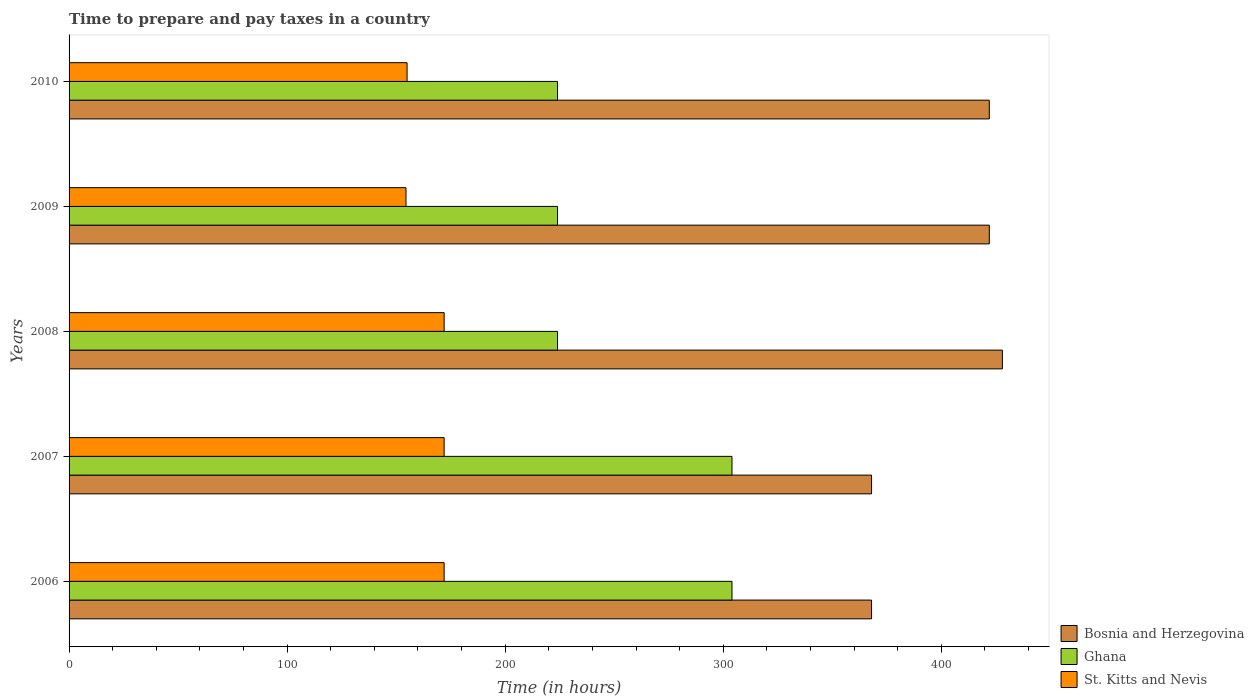Are the number of bars on each tick of the Y-axis equal?
Your answer should be very brief. Yes. How many bars are there on the 5th tick from the top?
Your response must be concise. 3. How many bars are there on the 3rd tick from the bottom?
Keep it short and to the point. 3. What is the number of hours required to prepare and pay taxes in Bosnia and Herzegovina in 2010?
Keep it short and to the point. 422. Across all years, what is the maximum number of hours required to prepare and pay taxes in Ghana?
Offer a terse response. 304. Across all years, what is the minimum number of hours required to prepare and pay taxes in Ghana?
Give a very brief answer. 224. In which year was the number of hours required to prepare and pay taxes in Ghana maximum?
Your response must be concise. 2006. In which year was the number of hours required to prepare and pay taxes in Bosnia and Herzegovina minimum?
Offer a very short reply. 2006. What is the total number of hours required to prepare and pay taxes in Ghana in the graph?
Ensure brevity in your answer.  1280. What is the difference between the number of hours required to prepare and pay taxes in St. Kitts and Nevis in 2007 and that in 2010?
Give a very brief answer. 17. What is the difference between the number of hours required to prepare and pay taxes in Bosnia and Herzegovina in 2008 and the number of hours required to prepare and pay taxes in Ghana in 2007?
Provide a short and direct response. 124. What is the average number of hours required to prepare and pay taxes in Bosnia and Herzegovina per year?
Your response must be concise. 401.6. In the year 2008, what is the difference between the number of hours required to prepare and pay taxes in Bosnia and Herzegovina and number of hours required to prepare and pay taxes in St. Kitts and Nevis?
Provide a succinct answer. 256. What is the ratio of the number of hours required to prepare and pay taxes in Bosnia and Herzegovina in 2008 to that in 2009?
Make the answer very short. 1.01. Is the difference between the number of hours required to prepare and pay taxes in Bosnia and Herzegovina in 2006 and 2009 greater than the difference between the number of hours required to prepare and pay taxes in St. Kitts and Nevis in 2006 and 2009?
Your answer should be compact. No. What is the difference between the highest and the second highest number of hours required to prepare and pay taxes in Ghana?
Offer a very short reply. 0. What is the difference between the highest and the lowest number of hours required to prepare and pay taxes in Ghana?
Offer a very short reply. 80. In how many years, is the number of hours required to prepare and pay taxes in Ghana greater than the average number of hours required to prepare and pay taxes in Ghana taken over all years?
Your response must be concise. 2. Is the sum of the number of hours required to prepare and pay taxes in Ghana in 2007 and 2008 greater than the maximum number of hours required to prepare and pay taxes in Bosnia and Herzegovina across all years?
Keep it short and to the point. Yes. What does the 1st bar from the top in 2006 represents?
Your answer should be compact. St. Kitts and Nevis. Is it the case that in every year, the sum of the number of hours required to prepare and pay taxes in Bosnia and Herzegovina and number of hours required to prepare and pay taxes in Ghana is greater than the number of hours required to prepare and pay taxes in St. Kitts and Nevis?
Ensure brevity in your answer.  Yes. What is the difference between two consecutive major ticks on the X-axis?
Provide a succinct answer. 100. Are the values on the major ticks of X-axis written in scientific E-notation?
Offer a very short reply. No. Does the graph contain any zero values?
Offer a terse response. No. Where does the legend appear in the graph?
Offer a terse response. Bottom right. How many legend labels are there?
Your response must be concise. 3. What is the title of the graph?
Provide a short and direct response. Time to prepare and pay taxes in a country. Does "Kenya" appear as one of the legend labels in the graph?
Offer a terse response. No. What is the label or title of the X-axis?
Offer a terse response. Time (in hours). What is the label or title of the Y-axis?
Your answer should be very brief. Years. What is the Time (in hours) of Bosnia and Herzegovina in 2006?
Offer a very short reply. 368. What is the Time (in hours) of Ghana in 2006?
Give a very brief answer. 304. What is the Time (in hours) of St. Kitts and Nevis in 2006?
Provide a succinct answer. 172. What is the Time (in hours) in Bosnia and Herzegovina in 2007?
Provide a short and direct response. 368. What is the Time (in hours) of Ghana in 2007?
Your answer should be compact. 304. What is the Time (in hours) in St. Kitts and Nevis in 2007?
Provide a short and direct response. 172. What is the Time (in hours) of Bosnia and Herzegovina in 2008?
Keep it short and to the point. 428. What is the Time (in hours) of Ghana in 2008?
Provide a succinct answer. 224. What is the Time (in hours) of St. Kitts and Nevis in 2008?
Provide a short and direct response. 172. What is the Time (in hours) of Bosnia and Herzegovina in 2009?
Provide a short and direct response. 422. What is the Time (in hours) of Ghana in 2009?
Offer a terse response. 224. What is the Time (in hours) of St. Kitts and Nevis in 2009?
Offer a very short reply. 154.5. What is the Time (in hours) in Bosnia and Herzegovina in 2010?
Keep it short and to the point. 422. What is the Time (in hours) in Ghana in 2010?
Give a very brief answer. 224. What is the Time (in hours) in St. Kitts and Nevis in 2010?
Your answer should be compact. 155. Across all years, what is the maximum Time (in hours) of Bosnia and Herzegovina?
Ensure brevity in your answer.  428. Across all years, what is the maximum Time (in hours) in Ghana?
Give a very brief answer. 304. Across all years, what is the maximum Time (in hours) in St. Kitts and Nevis?
Keep it short and to the point. 172. Across all years, what is the minimum Time (in hours) in Bosnia and Herzegovina?
Keep it short and to the point. 368. Across all years, what is the minimum Time (in hours) of Ghana?
Give a very brief answer. 224. Across all years, what is the minimum Time (in hours) in St. Kitts and Nevis?
Offer a very short reply. 154.5. What is the total Time (in hours) in Bosnia and Herzegovina in the graph?
Your answer should be very brief. 2008. What is the total Time (in hours) of Ghana in the graph?
Offer a terse response. 1280. What is the total Time (in hours) in St. Kitts and Nevis in the graph?
Provide a short and direct response. 825.5. What is the difference between the Time (in hours) of Bosnia and Herzegovina in 2006 and that in 2007?
Give a very brief answer. 0. What is the difference between the Time (in hours) in Ghana in 2006 and that in 2007?
Give a very brief answer. 0. What is the difference between the Time (in hours) of St. Kitts and Nevis in 2006 and that in 2007?
Keep it short and to the point. 0. What is the difference between the Time (in hours) in Bosnia and Herzegovina in 2006 and that in 2008?
Give a very brief answer. -60. What is the difference between the Time (in hours) in St. Kitts and Nevis in 2006 and that in 2008?
Provide a succinct answer. 0. What is the difference between the Time (in hours) of Bosnia and Herzegovina in 2006 and that in 2009?
Your response must be concise. -54. What is the difference between the Time (in hours) in Ghana in 2006 and that in 2009?
Your answer should be compact. 80. What is the difference between the Time (in hours) in St. Kitts and Nevis in 2006 and that in 2009?
Offer a very short reply. 17.5. What is the difference between the Time (in hours) in Bosnia and Herzegovina in 2006 and that in 2010?
Offer a terse response. -54. What is the difference between the Time (in hours) of Ghana in 2006 and that in 2010?
Provide a short and direct response. 80. What is the difference between the Time (in hours) in Bosnia and Herzegovina in 2007 and that in 2008?
Your answer should be compact. -60. What is the difference between the Time (in hours) in Ghana in 2007 and that in 2008?
Keep it short and to the point. 80. What is the difference between the Time (in hours) of Bosnia and Herzegovina in 2007 and that in 2009?
Make the answer very short. -54. What is the difference between the Time (in hours) of Bosnia and Herzegovina in 2007 and that in 2010?
Provide a succinct answer. -54. What is the difference between the Time (in hours) of Ghana in 2007 and that in 2010?
Offer a terse response. 80. What is the difference between the Time (in hours) of Ghana in 2008 and that in 2009?
Offer a terse response. 0. What is the difference between the Time (in hours) of Bosnia and Herzegovina in 2008 and that in 2010?
Offer a terse response. 6. What is the difference between the Time (in hours) of Ghana in 2008 and that in 2010?
Your response must be concise. 0. What is the difference between the Time (in hours) of St. Kitts and Nevis in 2008 and that in 2010?
Your answer should be very brief. 17. What is the difference between the Time (in hours) of Bosnia and Herzegovina in 2006 and the Time (in hours) of Ghana in 2007?
Make the answer very short. 64. What is the difference between the Time (in hours) in Bosnia and Herzegovina in 2006 and the Time (in hours) in St. Kitts and Nevis in 2007?
Offer a terse response. 196. What is the difference between the Time (in hours) in Ghana in 2006 and the Time (in hours) in St. Kitts and Nevis in 2007?
Give a very brief answer. 132. What is the difference between the Time (in hours) of Bosnia and Herzegovina in 2006 and the Time (in hours) of Ghana in 2008?
Your answer should be compact. 144. What is the difference between the Time (in hours) in Bosnia and Herzegovina in 2006 and the Time (in hours) in St. Kitts and Nevis in 2008?
Provide a short and direct response. 196. What is the difference between the Time (in hours) of Ghana in 2006 and the Time (in hours) of St. Kitts and Nevis in 2008?
Provide a succinct answer. 132. What is the difference between the Time (in hours) in Bosnia and Herzegovina in 2006 and the Time (in hours) in Ghana in 2009?
Your answer should be very brief. 144. What is the difference between the Time (in hours) of Bosnia and Herzegovina in 2006 and the Time (in hours) of St. Kitts and Nevis in 2009?
Offer a terse response. 213.5. What is the difference between the Time (in hours) in Ghana in 2006 and the Time (in hours) in St. Kitts and Nevis in 2009?
Make the answer very short. 149.5. What is the difference between the Time (in hours) of Bosnia and Herzegovina in 2006 and the Time (in hours) of Ghana in 2010?
Offer a very short reply. 144. What is the difference between the Time (in hours) in Bosnia and Herzegovina in 2006 and the Time (in hours) in St. Kitts and Nevis in 2010?
Your answer should be very brief. 213. What is the difference between the Time (in hours) of Ghana in 2006 and the Time (in hours) of St. Kitts and Nevis in 2010?
Ensure brevity in your answer.  149. What is the difference between the Time (in hours) of Bosnia and Herzegovina in 2007 and the Time (in hours) of Ghana in 2008?
Your response must be concise. 144. What is the difference between the Time (in hours) of Bosnia and Herzegovina in 2007 and the Time (in hours) of St. Kitts and Nevis in 2008?
Your answer should be compact. 196. What is the difference between the Time (in hours) of Ghana in 2007 and the Time (in hours) of St. Kitts and Nevis in 2008?
Keep it short and to the point. 132. What is the difference between the Time (in hours) of Bosnia and Herzegovina in 2007 and the Time (in hours) of Ghana in 2009?
Your response must be concise. 144. What is the difference between the Time (in hours) in Bosnia and Herzegovina in 2007 and the Time (in hours) in St. Kitts and Nevis in 2009?
Your response must be concise. 213.5. What is the difference between the Time (in hours) in Ghana in 2007 and the Time (in hours) in St. Kitts and Nevis in 2009?
Give a very brief answer. 149.5. What is the difference between the Time (in hours) of Bosnia and Herzegovina in 2007 and the Time (in hours) of Ghana in 2010?
Give a very brief answer. 144. What is the difference between the Time (in hours) of Bosnia and Herzegovina in 2007 and the Time (in hours) of St. Kitts and Nevis in 2010?
Keep it short and to the point. 213. What is the difference between the Time (in hours) in Ghana in 2007 and the Time (in hours) in St. Kitts and Nevis in 2010?
Ensure brevity in your answer.  149. What is the difference between the Time (in hours) of Bosnia and Herzegovina in 2008 and the Time (in hours) of Ghana in 2009?
Make the answer very short. 204. What is the difference between the Time (in hours) of Bosnia and Herzegovina in 2008 and the Time (in hours) of St. Kitts and Nevis in 2009?
Offer a terse response. 273.5. What is the difference between the Time (in hours) of Ghana in 2008 and the Time (in hours) of St. Kitts and Nevis in 2009?
Provide a succinct answer. 69.5. What is the difference between the Time (in hours) of Bosnia and Herzegovina in 2008 and the Time (in hours) of Ghana in 2010?
Your answer should be compact. 204. What is the difference between the Time (in hours) in Bosnia and Herzegovina in 2008 and the Time (in hours) in St. Kitts and Nevis in 2010?
Your response must be concise. 273. What is the difference between the Time (in hours) in Ghana in 2008 and the Time (in hours) in St. Kitts and Nevis in 2010?
Provide a succinct answer. 69. What is the difference between the Time (in hours) in Bosnia and Herzegovina in 2009 and the Time (in hours) in Ghana in 2010?
Give a very brief answer. 198. What is the difference between the Time (in hours) of Bosnia and Herzegovina in 2009 and the Time (in hours) of St. Kitts and Nevis in 2010?
Your response must be concise. 267. What is the average Time (in hours) of Bosnia and Herzegovina per year?
Keep it short and to the point. 401.6. What is the average Time (in hours) of Ghana per year?
Offer a very short reply. 256. What is the average Time (in hours) in St. Kitts and Nevis per year?
Your answer should be compact. 165.1. In the year 2006, what is the difference between the Time (in hours) in Bosnia and Herzegovina and Time (in hours) in Ghana?
Provide a short and direct response. 64. In the year 2006, what is the difference between the Time (in hours) of Bosnia and Herzegovina and Time (in hours) of St. Kitts and Nevis?
Your answer should be compact. 196. In the year 2006, what is the difference between the Time (in hours) in Ghana and Time (in hours) in St. Kitts and Nevis?
Your answer should be very brief. 132. In the year 2007, what is the difference between the Time (in hours) of Bosnia and Herzegovina and Time (in hours) of Ghana?
Offer a very short reply. 64. In the year 2007, what is the difference between the Time (in hours) in Bosnia and Herzegovina and Time (in hours) in St. Kitts and Nevis?
Make the answer very short. 196. In the year 2007, what is the difference between the Time (in hours) in Ghana and Time (in hours) in St. Kitts and Nevis?
Offer a very short reply. 132. In the year 2008, what is the difference between the Time (in hours) in Bosnia and Herzegovina and Time (in hours) in Ghana?
Offer a very short reply. 204. In the year 2008, what is the difference between the Time (in hours) in Bosnia and Herzegovina and Time (in hours) in St. Kitts and Nevis?
Offer a very short reply. 256. In the year 2008, what is the difference between the Time (in hours) of Ghana and Time (in hours) of St. Kitts and Nevis?
Your response must be concise. 52. In the year 2009, what is the difference between the Time (in hours) in Bosnia and Herzegovina and Time (in hours) in Ghana?
Provide a short and direct response. 198. In the year 2009, what is the difference between the Time (in hours) in Bosnia and Herzegovina and Time (in hours) in St. Kitts and Nevis?
Offer a very short reply. 267.5. In the year 2009, what is the difference between the Time (in hours) of Ghana and Time (in hours) of St. Kitts and Nevis?
Offer a terse response. 69.5. In the year 2010, what is the difference between the Time (in hours) in Bosnia and Herzegovina and Time (in hours) in Ghana?
Provide a succinct answer. 198. In the year 2010, what is the difference between the Time (in hours) of Bosnia and Herzegovina and Time (in hours) of St. Kitts and Nevis?
Your response must be concise. 267. What is the ratio of the Time (in hours) in Bosnia and Herzegovina in 2006 to that in 2007?
Provide a short and direct response. 1. What is the ratio of the Time (in hours) in Bosnia and Herzegovina in 2006 to that in 2008?
Give a very brief answer. 0.86. What is the ratio of the Time (in hours) of Ghana in 2006 to that in 2008?
Your answer should be compact. 1.36. What is the ratio of the Time (in hours) of Bosnia and Herzegovina in 2006 to that in 2009?
Give a very brief answer. 0.87. What is the ratio of the Time (in hours) of Ghana in 2006 to that in 2009?
Your answer should be very brief. 1.36. What is the ratio of the Time (in hours) of St. Kitts and Nevis in 2006 to that in 2009?
Offer a very short reply. 1.11. What is the ratio of the Time (in hours) in Bosnia and Herzegovina in 2006 to that in 2010?
Keep it short and to the point. 0.87. What is the ratio of the Time (in hours) in Ghana in 2006 to that in 2010?
Your response must be concise. 1.36. What is the ratio of the Time (in hours) in St. Kitts and Nevis in 2006 to that in 2010?
Give a very brief answer. 1.11. What is the ratio of the Time (in hours) of Bosnia and Herzegovina in 2007 to that in 2008?
Your answer should be compact. 0.86. What is the ratio of the Time (in hours) in Ghana in 2007 to that in 2008?
Make the answer very short. 1.36. What is the ratio of the Time (in hours) in St. Kitts and Nevis in 2007 to that in 2008?
Keep it short and to the point. 1. What is the ratio of the Time (in hours) in Bosnia and Herzegovina in 2007 to that in 2009?
Ensure brevity in your answer.  0.87. What is the ratio of the Time (in hours) in Ghana in 2007 to that in 2009?
Ensure brevity in your answer.  1.36. What is the ratio of the Time (in hours) in St. Kitts and Nevis in 2007 to that in 2009?
Keep it short and to the point. 1.11. What is the ratio of the Time (in hours) of Bosnia and Herzegovina in 2007 to that in 2010?
Give a very brief answer. 0.87. What is the ratio of the Time (in hours) in Ghana in 2007 to that in 2010?
Your answer should be very brief. 1.36. What is the ratio of the Time (in hours) of St. Kitts and Nevis in 2007 to that in 2010?
Give a very brief answer. 1.11. What is the ratio of the Time (in hours) of Bosnia and Herzegovina in 2008 to that in 2009?
Your answer should be very brief. 1.01. What is the ratio of the Time (in hours) of Ghana in 2008 to that in 2009?
Ensure brevity in your answer.  1. What is the ratio of the Time (in hours) in St. Kitts and Nevis in 2008 to that in 2009?
Offer a terse response. 1.11. What is the ratio of the Time (in hours) of Bosnia and Herzegovina in 2008 to that in 2010?
Give a very brief answer. 1.01. What is the ratio of the Time (in hours) in Ghana in 2008 to that in 2010?
Ensure brevity in your answer.  1. What is the ratio of the Time (in hours) of St. Kitts and Nevis in 2008 to that in 2010?
Provide a short and direct response. 1.11. What is the ratio of the Time (in hours) in St. Kitts and Nevis in 2009 to that in 2010?
Provide a succinct answer. 1. What is the difference between the highest and the second highest Time (in hours) in Ghana?
Make the answer very short. 0. What is the difference between the highest and the second highest Time (in hours) of St. Kitts and Nevis?
Your response must be concise. 0. What is the difference between the highest and the lowest Time (in hours) in Ghana?
Offer a terse response. 80. What is the difference between the highest and the lowest Time (in hours) of St. Kitts and Nevis?
Offer a terse response. 17.5. 